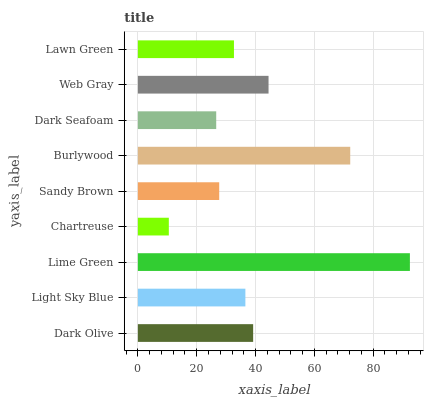Is Chartreuse the minimum?
Answer yes or no. Yes. Is Lime Green the maximum?
Answer yes or no. Yes. Is Light Sky Blue the minimum?
Answer yes or no. No. Is Light Sky Blue the maximum?
Answer yes or no. No. Is Dark Olive greater than Light Sky Blue?
Answer yes or no. Yes. Is Light Sky Blue less than Dark Olive?
Answer yes or no. Yes. Is Light Sky Blue greater than Dark Olive?
Answer yes or no. No. Is Dark Olive less than Light Sky Blue?
Answer yes or no. No. Is Light Sky Blue the high median?
Answer yes or no. Yes. Is Light Sky Blue the low median?
Answer yes or no. Yes. Is Chartreuse the high median?
Answer yes or no. No. Is Burlywood the low median?
Answer yes or no. No. 